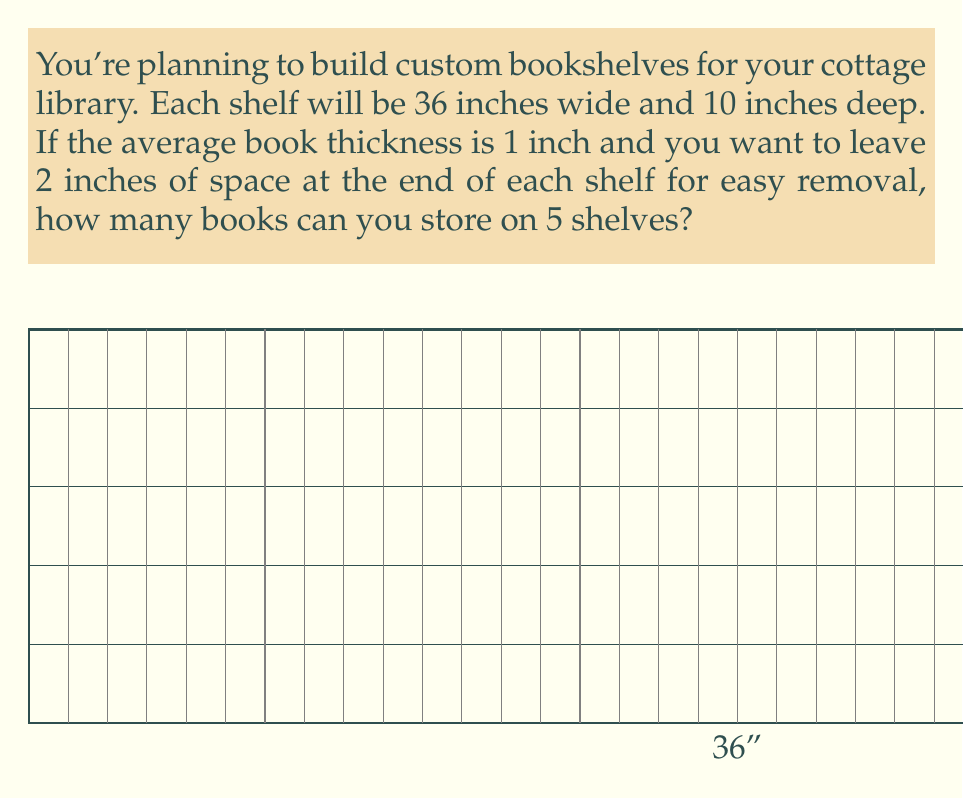Can you solve this math problem? Let's approach this step-by-step:

1) First, we need to calculate the usable space on each shelf:
   $$ \text{Usable space} = \text{Total width} - \text{Reserved space} $$
   $$ \text{Usable space} = 36 \text{ inches} - 2 \text{ inches} = 34 \text{ inches} $$

2) Now, we can calculate how many books can fit on one shelf:
   $$ \text{Books per shelf} = \frac{\text{Usable space}}{\text{Average book thickness}} $$
   $$ \text{Books per shelf} = \frac{34 \text{ inches}}{1 \text{ inch/book}} = 34 \text{ books} $$

3) Since we have 5 shelves, we multiply the number of books per shelf by 5:
   $$ \text{Total books} = \text{Books per shelf} \times \text{Number of shelves} $$
   $$ \text{Total books} = 34 \times 5 = 170 \text{ books} $$

Therefore, you can store 170 books on your custom bookshelves.
Answer: 170 books 